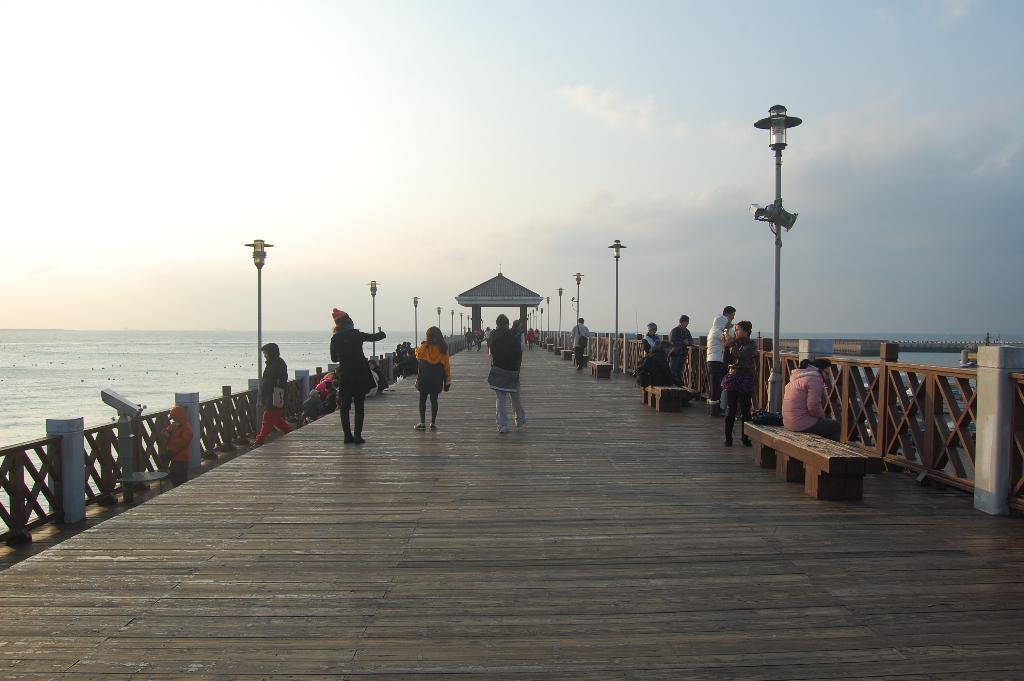In one or two sentences, can you explain what this image depicts? In this picture there is a group of men and women standing on the wooden bridge. On both the sides there is a river water. In the background there is a arch and dome lamp post. 